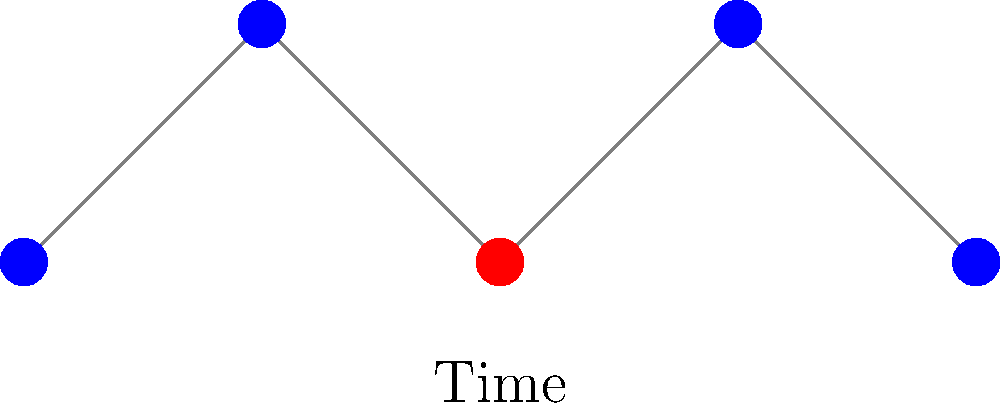In the time-series graph of network activity shown above, which analytical approach would be most effective in identifying the anomalous node behavior, and why is this method particularly suited for cybersecurity applications in large-scale networks? To identify the anomalous node behavior in this time-series graph of network activity, the most effective analytical approach would be:

1. Time-series analysis: This method is crucial because it considers the temporal aspect of the data, which is essential in network behavior analysis.

2. Statistical outlier detection: By calculating the mean and standard deviation of node activity over time, we can identify points that deviate significantly from the norm.

3. Graph-based anomaly detection: This technique considers the structural properties of the network and how they change over time.

4. Machine learning algorithms: Techniques such as clustering or classification can be used to identify patterns and anomalies in the data.

5. Threshold-based detection: Setting activity thresholds based on historical data can help identify sudden spikes or drops in network activity.

The most effective approach for this scenario would be a combination of time-series analysis and statistical outlier detection. This method is particularly suited for cybersecurity applications in large-scale networks because:

a) It can handle high-dimensional data typical in large networks.
b) It's computationally efficient, allowing for real-time or near-real-time analysis.
c) It can adapt to changing network conditions and learn from new data.
d) It's less prone to false positives compared to simple threshold-based methods.
e) It can detect subtle anomalies that might be missed by rule-based systems.

In practice, this would involve:
1. Calculating the moving average $\mu$ and standard deviation $\sigma$ of network activity over time.
2. For each time point $t$, compute the Z-score: $Z_t = \frac{x_t - \mu}{\sigma}$
3. Flag any point where $|Z_t| > k$, where $k$ is a chosen threshold (typically 2 or 3).

This approach would effectively identify the red node in the graph as anomalous, as it represents a significant deviation from the established pattern of activity.
Answer: Time-series analysis combined with statistical outlier detection 